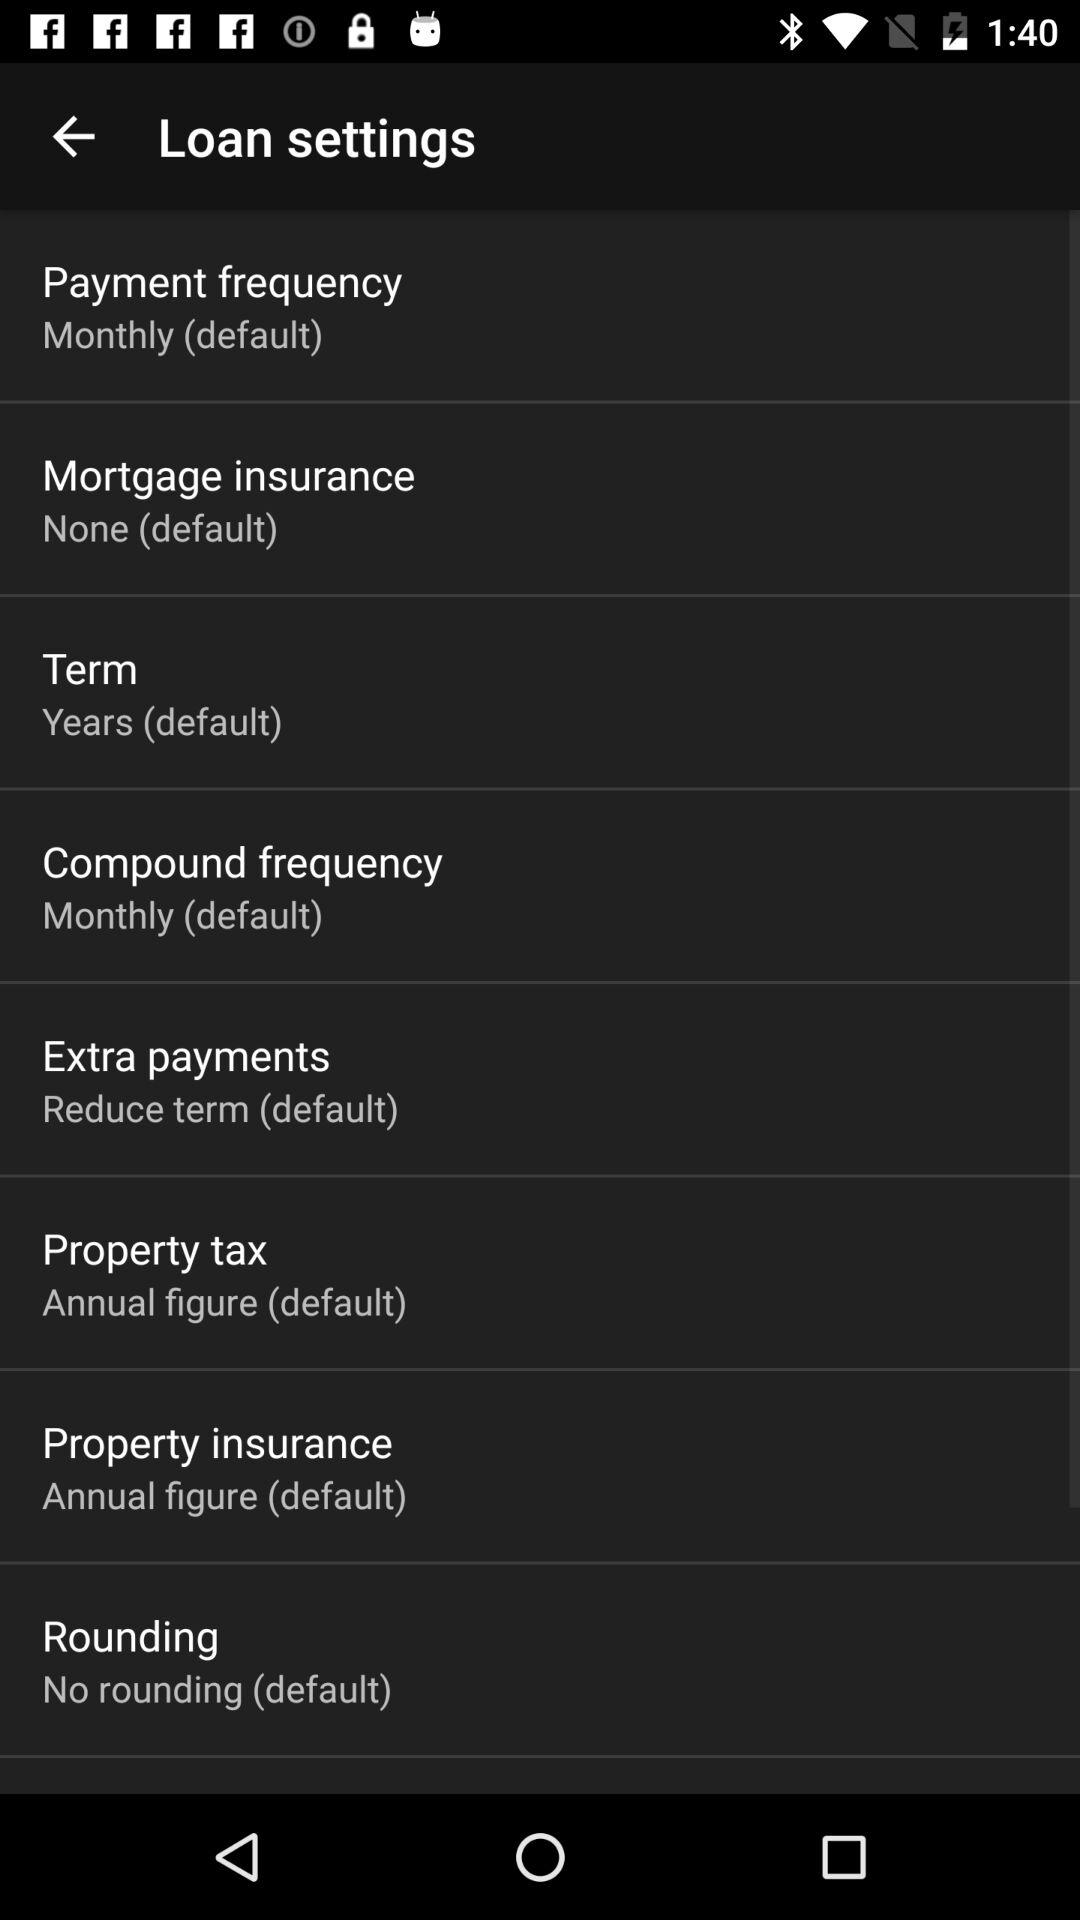What is the setting for payment frequency? The setting for payment frequency is "Monthly (default)". 